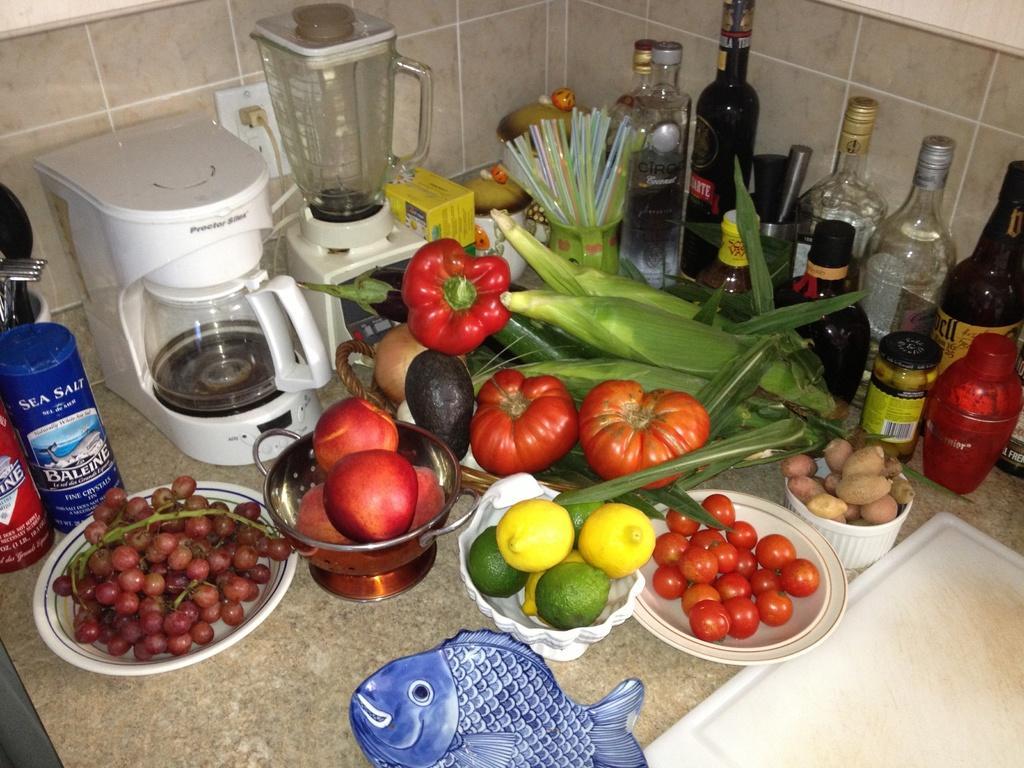How would you summarize this image in a sentence or two? In this image there are fruits, vegetables in bowls and there are bottles, straws, a blender, kettle, a tray and some other objects on the kitchen platform, behind that there is a tile wall. 